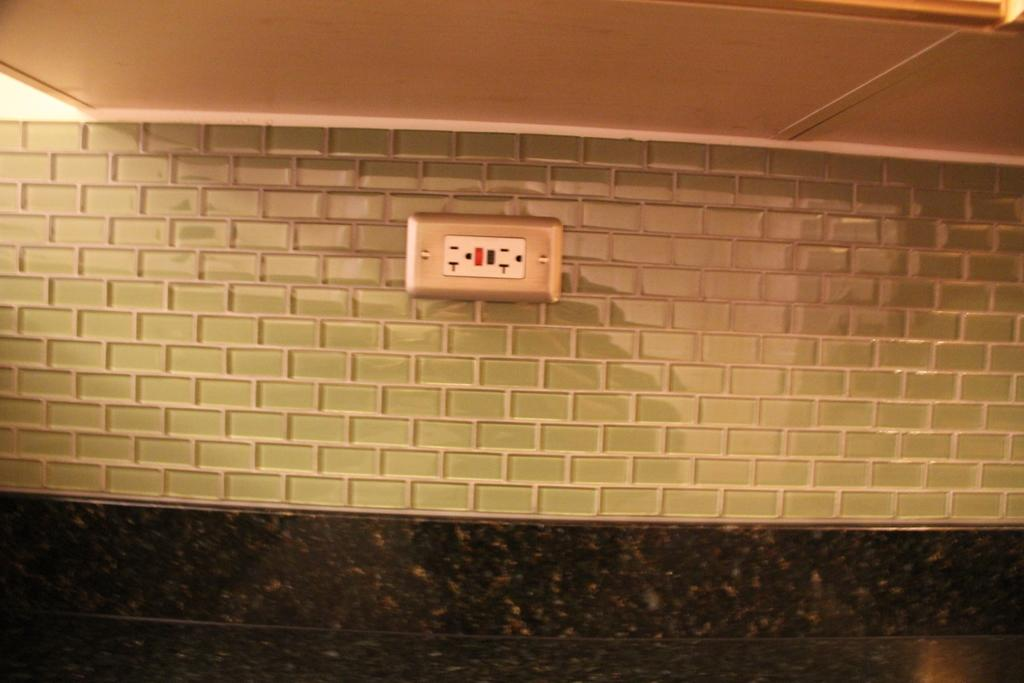What can be found on the wall in the image? There is a socket on the wall in the image. What type of calendar is hanging next to the socket in the image? There is no calendar present in the image; only the socket on the wall is visible. Can you see any worms crawling on the socket in the image? There are no worms present in the image; only the socket on the wall is visible. 